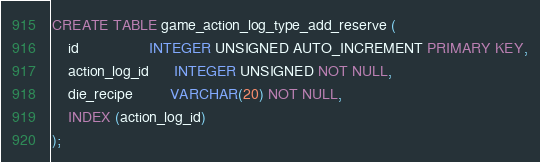<code> <loc_0><loc_0><loc_500><loc_500><_SQL_>CREATE TABLE game_action_log_type_add_reserve (
    id                 INTEGER UNSIGNED AUTO_INCREMENT PRIMARY KEY,
    action_log_id      INTEGER UNSIGNED NOT NULL,
    die_recipe         VARCHAR(20) NOT NULL, 
    INDEX (action_log_id)
);  
</code> 